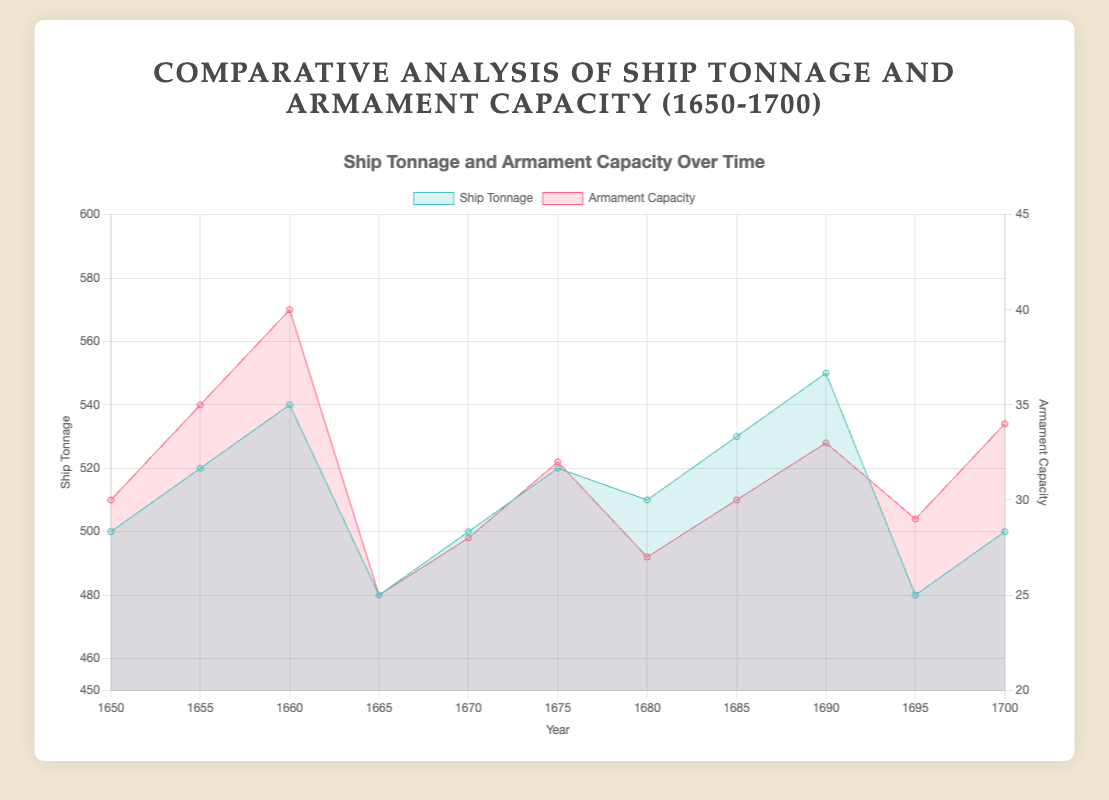What is the title of the chart? The title of the chart is the text displayed prominently at the top of the figure, which captures the main subject of the data visualization.
Answer: Comparative Analysis of Ship Tonnage and Armament Capacity (1650-1700) Which country had the highest armament capacity in 1650? To find this, look for the data point for 1650 and check the dataset associated with armament capacity.
Answer: England How did the ship tonnage of Spain change from 1680 to 1690? Check the values for ship tonnage in the years 1680 and 1690 for Spain, then compare those values to see the change. In 1680, it was 510, and in 1690, it was 550.
Answer: Increased by 40 units In which year did England's armament capacity reach 40? Look at the armament capacity data points and identify the year when England’s capacity hit 40.
Answer: 1660 What was the average ship tonnage of France during the 1670s? Find the ship tonnage values for France in the years 1670 and 1675. Add these values and divide by the number of data points to get the average. (\(500 + 520) / 2 = 510
Answer: 510 Which country had an armament capacity of 34 in 1700? Look at the armament capacity data for the year 1700, and then identify the corresponding country.
Answer: Netherlands How does the ship tonnage trend over time for England from 1650 to 1660 look? Observe the ship tonnage values for England in the years 1650, 1655, and 1660 and determine the trend. It increases consistently.
Answer: Increasing trend What was the difference in armament capacity between France and Spain in 1680? Find the armament capacity of France and Spain in 1680 and then calculate the difference. France is not in the data for 1680, only Spain's capacity of 27. Hence, this question may not be directly answerable.
Answer: N/A Which country showed a consistent increase in ship tonnage between 1650 and 1700? Review the ship tonnage values for each country over time to see which country's values consistently rose. England's values from 1650 to 1660 show consistent increase.
Answer: England What is the relationship between armament capacity and ship tonnage for Spain in 1690? Look at the data points for Spain in 1690. Compare the armament capacity and ship tonnage values to understand their relationship. Armament capacity is 33, and ship tonnage is 550. Generally, as armament capacity increases, ship tonnage also increases.
Answer: Positive correlation Which year saw the highest ship tonnage overall, and what was the value? Scan through all the ship tonnage values from 1650 to 1700 for all countries represented, and identify the highest value and its year. In 1690, the ship tonnage value is the highest at 550.
Answer: 1690, 550 